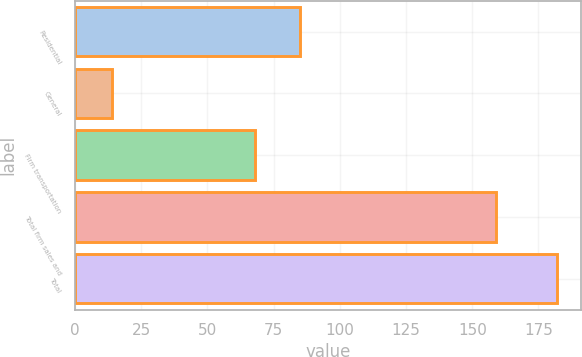Convert chart to OTSL. <chart><loc_0><loc_0><loc_500><loc_500><bar_chart><fcel>Residential<fcel>General<fcel>Firm transportation<fcel>Total firm sales and<fcel>Total<nl><fcel>84.8<fcel>14<fcel>68<fcel>159<fcel>182<nl></chart> 